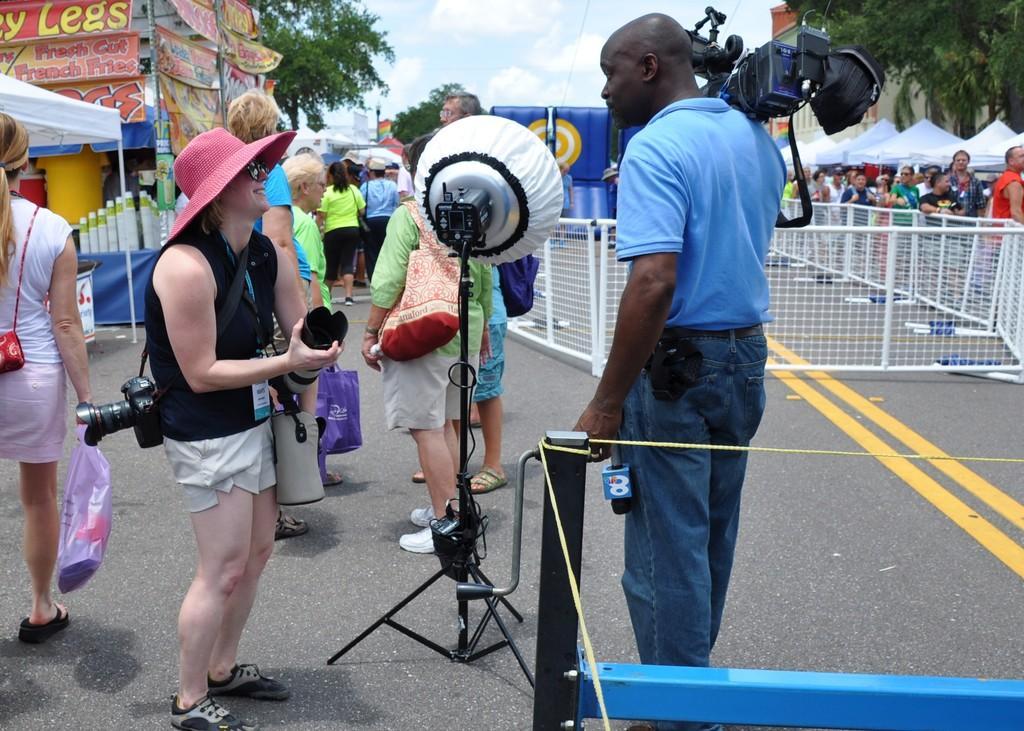Please provide a concise description of this image. In the middle of the image few people are standing and holding something in their hands. Behind them there are some tents and fencing and trees. At the top of the image there are some clouds and sky. 